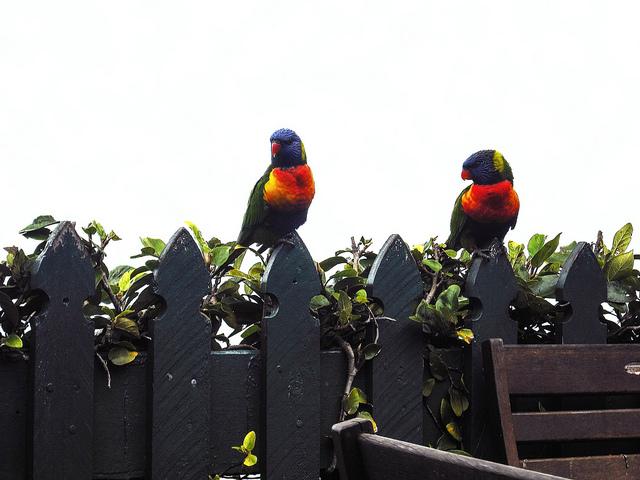What is sitting against the fence?
Be succinct. Chair. What do the birds sit on?
Quick response, please. Fence. Are the fence posts wide enough for the birds to perch?
Concise answer only. Yes. 